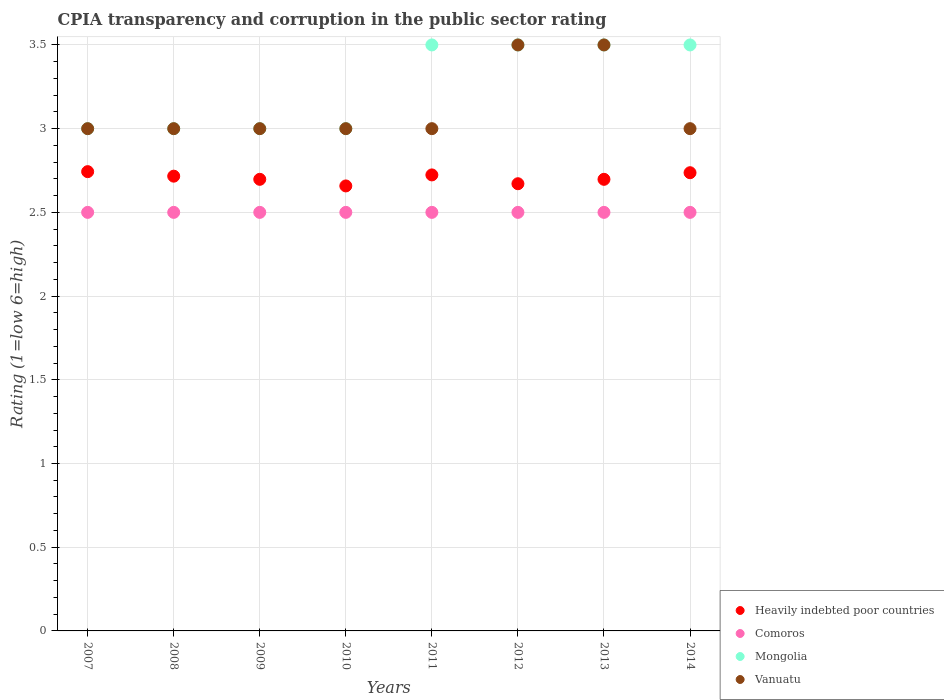Is the number of dotlines equal to the number of legend labels?
Offer a very short reply. Yes. Across all years, what is the maximum CPIA rating in Vanuatu?
Your answer should be compact. 3.5. Across all years, what is the minimum CPIA rating in Vanuatu?
Provide a succinct answer. 3. In which year was the CPIA rating in Vanuatu maximum?
Your response must be concise. 2012. In which year was the CPIA rating in Comoros minimum?
Provide a succinct answer. 2007. What is the difference between the CPIA rating in Mongolia in 2007 and that in 2012?
Offer a terse response. -0.5. In the year 2011, what is the difference between the CPIA rating in Vanuatu and CPIA rating in Heavily indebted poor countries?
Provide a short and direct response. 0.28. In how many years, is the CPIA rating in Comoros greater than 1.5?
Ensure brevity in your answer.  8. Is the CPIA rating in Heavily indebted poor countries in 2011 less than that in 2014?
Your response must be concise. Yes. What is the difference between the highest and the second highest CPIA rating in Heavily indebted poor countries?
Ensure brevity in your answer.  0.01. What is the difference between the highest and the lowest CPIA rating in Vanuatu?
Your answer should be compact. 0.5. Is the sum of the CPIA rating in Heavily indebted poor countries in 2010 and 2014 greater than the maximum CPIA rating in Vanuatu across all years?
Your answer should be compact. Yes. Is it the case that in every year, the sum of the CPIA rating in Mongolia and CPIA rating in Vanuatu  is greater than the sum of CPIA rating in Heavily indebted poor countries and CPIA rating in Comoros?
Provide a succinct answer. Yes. Is the CPIA rating in Heavily indebted poor countries strictly less than the CPIA rating in Comoros over the years?
Provide a short and direct response. No. Does the graph contain any zero values?
Ensure brevity in your answer.  No. Where does the legend appear in the graph?
Make the answer very short. Bottom right. What is the title of the graph?
Give a very brief answer. CPIA transparency and corruption in the public sector rating. Does "United States" appear as one of the legend labels in the graph?
Provide a short and direct response. No. What is the label or title of the X-axis?
Provide a short and direct response. Years. What is the Rating (1=low 6=high) of Heavily indebted poor countries in 2007?
Offer a terse response. 2.74. What is the Rating (1=low 6=high) of Heavily indebted poor countries in 2008?
Your answer should be very brief. 2.72. What is the Rating (1=low 6=high) in Mongolia in 2008?
Your answer should be compact. 3. What is the Rating (1=low 6=high) in Heavily indebted poor countries in 2009?
Give a very brief answer. 2.7. What is the Rating (1=low 6=high) in Vanuatu in 2009?
Your answer should be compact. 3. What is the Rating (1=low 6=high) of Heavily indebted poor countries in 2010?
Your response must be concise. 2.66. What is the Rating (1=low 6=high) of Vanuatu in 2010?
Offer a very short reply. 3. What is the Rating (1=low 6=high) in Heavily indebted poor countries in 2011?
Provide a succinct answer. 2.72. What is the Rating (1=low 6=high) in Heavily indebted poor countries in 2012?
Your answer should be compact. 2.67. What is the Rating (1=low 6=high) of Heavily indebted poor countries in 2013?
Provide a succinct answer. 2.7. What is the Rating (1=low 6=high) of Comoros in 2013?
Your answer should be very brief. 2.5. What is the Rating (1=low 6=high) of Heavily indebted poor countries in 2014?
Provide a succinct answer. 2.74. What is the Rating (1=low 6=high) of Mongolia in 2014?
Your response must be concise. 3.5. Across all years, what is the maximum Rating (1=low 6=high) in Heavily indebted poor countries?
Provide a succinct answer. 2.74. Across all years, what is the maximum Rating (1=low 6=high) of Vanuatu?
Make the answer very short. 3.5. Across all years, what is the minimum Rating (1=low 6=high) of Heavily indebted poor countries?
Keep it short and to the point. 2.66. Across all years, what is the minimum Rating (1=low 6=high) in Mongolia?
Make the answer very short. 3. What is the total Rating (1=low 6=high) in Heavily indebted poor countries in the graph?
Provide a short and direct response. 21.64. What is the total Rating (1=low 6=high) in Comoros in the graph?
Provide a succinct answer. 20. What is the total Rating (1=low 6=high) of Mongolia in the graph?
Offer a very short reply. 26. What is the difference between the Rating (1=low 6=high) of Heavily indebted poor countries in 2007 and that in 2008?
Your response must be concise. 0.03. What is the difference between the Rating (1=low 6=high) of Comoros in 2007 and that in 2008?
Offer a terse response. 0. What is the difference between the Rating (1=low 6=high) in Mongolia in 2007 and that in 2008?
Offer a terse response. 0. What is the difference between the Rating (1=low 6=high) of Vanuatu in 2007 and that in 2008?
Give a very brief answer. 0. What is the difference between the Rating (1=low 6=high) in Heavily indebted poor countries in 2007 and that in 2009?
Offer a very short reply. 0.05. What is the difference between the Rating (1=low 6=high) in Mongolia in 2007 and that in 2009?
Your answer should be compact. 0. What is the difference between the Rating (1=low 6=high) in Heavily indebted poor countries in 2007 and that in 2010?
Offer a terse response. 0.09. What is the difference between the Rating (1=low 6=high) in Heavily indebted poor countries in 2007 and that in 2011?
Keep it short and to the point. 0.02. What is the difference between the Rating (1=low 6=high) of Comoros in 2007 and that in 2011?
Give a very brief answer. 0. What is the difference between the Rating (1=low 6=high) in Vanuatu in 2007 and that in 2011?
Provide a short and direct response. 0. What is the difference between the Rating (1=low 6=high) in Heavily indebted poor countries in 2007 and that in 2012?
Offer a very short reply. 0.07. What is the difference between the Rating (1=low 6=high) of Mongolia in 2007 and that in 2012?
Keep it short and to the point. -0.5. What is the difference between the Rating (1=low 6=high) of Vanuatu in 2007 and that in 2012?
Offer a very short reply. -0.5. What is the difference between the Rating (1=low 6=high) in Heavily indebted poor countries in 2007 and that in 2013?
Your answer should be very brief. 0.05. What is the difference between the Rating (1=low 6=high) in Comoros in 2007 and that in 2013?
Offer a very short reply. 0. What is the difference between the Rating (1=low 6=high) in Mongolia in 2007 and that in 2013?
Offer a very short reply. -0.5. What is the difference between the Rating (1=low 6=high) of Heavily indebted poor countries in 2007 and that in 2014?
Ensure brevity in your answer.  0.01. What is the difference between the Rating (1=low 6=high) of Mongolia in 2007 and that in 2014?
Provide a succinct answer. -0.5. What is the difference between the Rating (1=low 6=high) of Heavily indebted poor countries in 2008 and that in 2009?
Offer a terse response. 0.02. What is the difference between the Rating (1=low 6=high) of Heavily indebted poor countries in 2008 and that in 2010?
Give a very brief answer. 0.06. What is the difference between the Rating (1=low 6=high) of Vanuatu in 2008 and that in 2010?
Your answer should be compact. 0. What is the difference between the Rating (1=low 6=high) of Heavily indebted poor countries in 2008 and that in 2011?
Your answer should be compact. -0.01. What is the difference between the Rating (1=low 6=high) in Mongolia in 2008 and that in 2011?
Your response must be concise. -0.5. What is the difference between the Rating (1=low 6=high) of Vanuatu in 2008 and that in 2011?
Keep it short and to the point. 0. What is the difference between the Rating (1=low 6=high) of Heavily indebted poor countries in 2008 and that in 2012?
Provide a short and direct response. 0.05. What is the difference between the Rating (1=low 6=high) of Heavily indebted poor countries in 2008 and that in 2013?
Provide a succinct answer. 0.02. What is the difference between the Rating (1=low 6=high) in Heavily indebted poor countries in 2008 and that in 2014?
Your answer should be compact. -0.02. What is the difference between the Rating (1=low 6=high) of Heavily indebted poor countries in 2009 and that in 2010?
Make the answer very short. 0.04. What is the difference between the Rating (1=low 6=high) in Mongolia in 2009 and that in 2010?
Your response must be concise. 0. What is the difference between the Rating (1=low 6=high) in Heavily indebted poor countries in 2009 and that in 2011?
Keep it short and to the point. -0.03. What is the difference between the Rating (1=low 6=high) in Comoros in 2009 and that in 2011?
Give a very brief answer. 0. What is the difference between the Rating (1=low 6=high) in Heavily indebted poor countries in 2009 and that in 2012?
Ensure brevity in your answer.  0.03. What is the difference between the Rating (1=low 6=high) in Comoros in 2009 and that in 2012?
Offer a very short reply. 0. What is the difference between the Rating (1=low 6=high) in Mongolia in 2009 and that in 2012?
Keep it short and to the point. -0.5. What is the difference between the Rating (1=low 6=high) in Vanuatu in 2009 and that in 2012?
Ensure brevity in your answer.  -0.5. What is the difference between the Rating (1=low 6=high) in Heavily indebted poor countries in 2009 and that in 2013?
Your answer should be very brief. 0. What is the difference between the Rating (1=low 6=high) of Comoros in 2009 and that in 2013?
Your answer should be very brief. 0. What is the difference between the Rating (1=low 6=high) of Mongolia in 2009 and that in 2013?
Your response must be concise. -0.5. What is the difference between the Rating (1=low 6=high) in Heavily indebted poor countries in 2009 and that in 2014?
Provide a short and direct response. -0.04. What is the difference between the Rating (1=low 6=high) in Heavily indebted poor countries in 2010 and that in 2011?
Provide a succinct answer. -0.07. What is the difference between the Rating (1=low 6=high) in Comoros in 2010 and that in 2011?
Your answer should be compact. 0. What is the difference between the Rating (1=low 6=high) in Heavily indebted poor countries in 2010 and that in 2012?
Provide a short and direct response. -0.01. What is the difference between the Rating (1=low 6=high) of Heavily indebted poor countries in 2010 and that in 2013?
Your answer should be compact. -0.04. What is the difference between the Rating (1=low 6=high) of Comoros in 2010 and that in 2013?
Your response must be concise. 0. What is the difference between the Rating (1=low 6=high) in Heavily indebted poor countries in 2010 and that in 2014?
Make the answer very short. -0.08. What is the difference between the Rating (1=low 6=high) in Comoros in 2010 and that in 2014?
Give a very brief answer. 0. What is the difference between the Rating (1=low 6=high) of Mongolia in 2010 and that in 2014?
Your answer should be very brief. -0.5. What is the difference between the Rating (1=low 6=high) in Vanuatu in 2010 and that in 2014?
Give a very brief answer. 0. What is the difference between the Rating (1=low 6=high) in Heavily indebted poor countries in 2011 and that in 2012?
Ensure brevity in your answer.  0.05. What is the difference between the Rating (1=low 6=high) in Vanuatu in 2011 and that in 2012?
Provide a succinct answer. -0.5. What is the difference between the Rating (1=low 6=high) in Heavily indebted poor countries in 2011 and that in 2013?
Provide a succinct answer. 0.03. What is the difference between the Rating (1=low 6=high) in Comoros in 2011 and that in 2013?
Offer a terse response. 0. What is the difference between the Rating (1=low 6=high) in Vanuatu in 2011 and that in 2013?
Provide a succinct answer. -0.5. What is the difference between the Rating (1=low 6=high) of Heavily indebted poor countries in 2011 and that in 2014?
Ensure brevity in your answer.  -0.01. What is the difference between the Rating (1=low 6=high) of Mongolia in 2011 and that in 2014?
Your answer should be very brief. 0. What is the difference between the Rating (1=low 6=high) of Vanuatu in 2011 and that in 2014?
Offer a terse response. 0. What is the difference between the Rating (1=low 6=high) in Heavily indebted poor countries in 2012 and that in 2013?
Offer a very short reply. -0.03. What is the difference between the Rating (1=low 6=high) in Comoros in 2012 and that in 2013?
Give a very brief answer. 0. What is the difference between the Rating (1=low 6=high) of Vanuatu in 2012 and that in 2013?
Make the answer very short. 0. What is the difference between the Rating (1=low 6=high) in Heavily indebted poor countries in 2012 and that in 2014?
Make the answer very short. -0.07. What is the difference between the Rating (1=low 6=high) in Comoros in 2012 and that in 2014?
Your answer should be very brief. 0. What is the difference between the Rating (1=low 6=high) of Mongolia in 2012 and that in 2014?
Offer a terse response. 0. What is the difference between the Rating (1=low 6=high) in Vanuatu in 2012 and that in 2014?
Provide a succinct answer. 0.5. What is the difference between the Rating (1=low 6=high) of Heavily indebted poor countries in 2013 and that in 2014?
Make the answer very short. -0.04. What is the difference between the Rating (1=low 6=high) of Comoros in 2013 and that in 2014?
Your answer should be very brief. 0. What is the difference between the Rating (1=low 6=high) in Vanuatu in 2013 and that in 2014?
Make the answer very short. 0.5. What is the difference between the Rating (1=low 6=high) in Heavily indebted poor countries in 2007 and the Rating (1=low 6=high) in Comoros in 2008?
Give a very brief answer. 0.24. What is the difference between the Rating (1=low 6=high) of Heavily indebted poor countries in 2007 and the Rating (1=low 6=high) of Mongolia in 2008?
Provide a succinct answer. -0.26. What is the difference between the Rating (1=low 6=high) in Heavily indebted poor countries in 2007 and the Rating (1=low 6=high) in Vanuatu in 2008?
Provide a short and direct response. -0.26. What is the difference between the Rating (1=low 6=high) in Comoros in 2007 and the Rating (1=low 6=high) in Mongolia in 2008?
Keep it short and to the point. -0.5. What is the difference between the Rating (1=low 6=high) of Comoros in 2007 and the Rating (1=low 6=high) of Vanuatu in 2008?
Offer a terse response. -0.5. What is the difference between the Rating (1=low 6=high) in Heavily indebted poor countries in 2007 and the Rating (1=low 6=high) in Comoros in 2009?
Offer a terse response. 0.24. What is the difference between the Rating (1=low 6=high) in Heavily indebted poor countries in 2007 and the Rating (1=low 6=high) in Mongolia in 2009?
Provide a succinct answer. -0.26. What is the difference between the Rating (1=low 6=high) in Heavily indebted poor countries in 2007 and the Rating (1=low 6=high) in Vanuatu in 2009?
Provide a short and direct response. -0.26. What is the difference between the Rating (1=low 6=high) in Comoros in 2007 and the Rating (1=low 6=high) in Mongolia in 2009?
Keep it short and to the point. -0.5. What is the difference between the Rating (1=low 6=high) in Comoros in 2007 and the Rating (1=low 6=high) in Vanuatu in 2009?
Provide a short and direct response. -0.5. What is the difference between the Rating (1=low 6=high) of Heavily indebted poor countries in 2007 and the Rating (1=low 6=high) of Comoros in 2010?
Ensure brevity in your answer.  0.24. What is the difference between the Rating (1=low 6=high) of Heavily indebted poor countries in 2007 and the Rating (1=low 6=high) of Mongolia in 2010?
Keep it short and to the point. -0.26. What is the difference between the Rating (1=low 6=high) of Heavily indebted poor countries in 2007 and the Rating (1=low 6=high) of Vanuatu in 2010?
Keep it short and to the point. -0.26. What is the difference between the Rating (1=low 6=high) of Comoros in 2007 and the Rating (1=low 6=high) of Mongolia in 2010?
Offer a terse response. -0.5. What is the difference between the Rating (1=low 6=high) of Comoros in 2007 and the Rating (1=low 6=high) of Vanuatu in 2010?
Your answer should be compact. -0.5. What is the difference between the Rating (1=low 6=high) in Mongolia in 2007 and the Rating (1=low 6=high) in Vanuatu in 2010?
Offer a very short reply. 0. What is the difference between the Rating (1=low 6=high) in Heavily indebted poor countries in 2007 and the Rating (1=low 6=high) in Comoros in 2011?
Offer a terse response. 0.24. What is the difference between the Rating (1=low 6=high) of Heavily indebted poor countries in 2007 and the Rating (1=low 6=high) of Mongolia in 2011?
Give a very brief answer. -0.76. What is the difference between the Rating (1=low 6=high) in Heavily indebted poor countries in 2007 and the Rating (1=low 6=high) in Vanuatu in 2011?
Your answer should be very brief. -0.26. What is the difference between the Rating (1=low 6=high) of Mongolia in 2007 and the Rating (1=low 6=high) of Vanuatu in 2011?
Your response must be concise. 0. What is the difference between the Rating (1=low 6=high) of Heavily indebted poor countries in 2007 and the Rating (1=low 6=high) of Comoros in 2012?
Make the answer very short. 0.24. What is the difference between the Rating (1=low 6=high) of Heavily indebted poor countries in 2007 and the Rating (1=low 6=high) of Mongolia in 2012?
Offer a very short reply. -0.76. What is the difference between the Rating (1=low 6=high) of Heavily indebted poor countries in 2007 and the Rating (1=low 6=high) of Vanuatu in 2012?
Offer a very short reply. -0.76. What is the difference between the Rating (1=low 6=high) in Comoros in 2007 and the Rating (1=low 6=high) in Mongolia in 2012?
Make the answer very short. -1. What is the difference between the Rating (1=low 6=high) of Mongolia in 2007 and the Rating (1=low 6=high) of Vanuatu in 2012?
Ensure brevity in your answer.  -0.5. What is the difference between the Rating (1=low 6=high) in Heavily indebted poor countries in 2007 and the Rating (1=low 6=high) in Comoros in 2013?
Your response must be concise. 0.24. What is the difference between the Rating (1=low 6=high) in Heavily indebted poor countries in 2007 and the Rating (1=low 6=high) in Mongolia in 2013?
Offer a very short reply. -0.76. What is the difference between the Rating (1=low 6=high) in Heavily indebted poor countries in 2007 and the Rating (1=low 6=high) in Vanuatu in 2013?
Your answer should be compact. -0.76. What is the difference between the Rating (1=low 6=high) of Comoros in 2007 and the Rating (1=low 6=high) of Mongolia in 2013?
Make the answer very short. -1. What is the difference between the Rating (1=low 6=high) in Comoros in 2007 and the Rating (1=low 6=high) in Vanuatu in 2013?
Provide a short and direct response. -1. What is the difference between the Rating (1=low 6=high) of Heavily indebted poor countries in 2007 and the Rating (1=low 6=high) of Comoros in 2014?
Your answer should be very brief. 0.24. What is the difference between the Rating (1=low 6=high) in Heavily indebted poor countries in 2007 and the Rating (1=low 6=high) in Mongolia in 2014?
Offer a very short reply. -0.76. What is the difference between the Rating (1=low 6=high) in Heavily indebted poor countries in 2007 and the Rating (1=low 6=high) in Vanuatu in 2014?
Your response must be concise. -0.26. What is the difference between the Rating (1=low 6=high) of Comoros in 2007 and the Rating (1=low 6=high) of Vanuatu in 2014?
Your response must be concise. -0.5. What is the difference between the Rating (1=low 6=high) in Mongolia in 2007 and the Rating (1=low 6=high) in Vanuatu in 2014?
Your answer should be compact. 0. What is the difference between the Rating (1=low 6=high) of Heavily indebted poor countries in 2008 and the Rating (1=low 6=high) of Comoros in 2009?
Make the answer very short. 0.22. What is the difference between the Rating (1=low 6=high) in Heavily indebted poor countries in 2008 and the Rating (1=low 6=high) in Mongolia in 2009?
Provide a short and direct response. -0.28. What is the difference between the Rating (1=low 6=high) of Heavily indebted poor countries in 2008 and the Rating (1=low 6=high) of Vanuatu in 2009?
Your answer should be compact. -0.28. What is the difference between the Rating (1=low 6=high) in Comoros in 2008 and the Rating (1=low 6=high) in Mongolia in 2009?
Offer a terse response. -0.5. What is the difference between the Rating (1=low 6=high) of Heavily indebted poor countries in 2008 and the Rating (1=low 6=high) of Comoros in 2010?
Offer a very short reply. 0.22. What is the difference between the Rating (1=low 6=high) of Heavily indebted poor countries in 2008 and the Rating (1=low 6=high) of Mongolia in 2010?
Offer a terse response. -0.28. What is the difference between the Rating (1=low 6=high) in Heavily indebted poor countries in 2008 and the Rating (1=low 6=high) in Vanuatu in 2010?
Offer a terse response. -0.28. What is the difference between the Rating (1=low 6=high) of Comoros in 2008 and the Rating (1=low 6=high) of Mongolia in 2010?
Your response must be concise. -0.5. What is the difference between the Rating (1=low 6=high) in Mongolia in 2008 and the Rating (1=low 6=high) in Vanuatu in 2010?
Provide a succinct answer. 0. What is the difference between the Rating (1=low 6=high) in Heavily indebted poor countries in 2008 and the Rating (1=low 6=high) in Comoros in 2011?
Give a very brief answer. 0.22. What is the difference between the Rating (1=low 6=high) of Heavily indebted poor countries in 2008 and the Rating (1=low 6=high) of Mongolia in 2011?
Give a very brief answer. -0.78. What is the difference between the Rating (1=low 6=high) of Heavily indebted poor countries in 2008 and the Rating (1=low 6=high) of Vanuatu in 2011?
Provide a succinct answer. -0.28. What is the difference between the Rating (1=low 6=high) in Comoros in 2008 and the Rating (1=low 6=high) in Mongolia in 2011?
Provide a short and direct response. -1. What is the difference between the Rating (1=low 6=high) of Comoros in 2008 and the Rating (1=low 6=high) of Vanuatu in 2011?
Keep it short and to the point. -0.5. What is the difference between the Rating (1=low 6=high) of Mongolia in 2008 and the Rating (1=low 6=high) of Vanuatu in 2011?
Make the answer very short. 0. What is the difference between the Rating (1=low 6=high) of Heavily indebted poor countries in 2008 and the Rating (1=low 6=high) of Comoros in 2012?
Provide a short and direct response. 0.22. What is the difference between the Rating (1=low 6=high) in Heavily indebted poor countries in 2008 and the Rating (1=low 6=high) in Mongolia in 2012?
Offer a very short reply. -0.78. What is the difference between the Rating (1=low 6=high) of Heavily indebted poor countries in 2008 and the Rating (1=low 6=high) of Vanuatu in 2012?
Give a very brief answer. -0.78. What is the difference between the Rating (1=low 6=high) in Comoros in 2008 and the Rating (1=low 6=high) in Mongolia in 2012?
Ensure brevity in your answer.  -1. What is the difference between the Rating (1=low 6=high) of Comoros in 2008 and the Rating (1=low 6=high) of Vanuatu in 2012?
Your answer should be very brief. -1. What is the difference between the Rating (1=low 6=high) in Heavily indebted poor countries in 2008 and the Rating (1=low 6=high) in Comoros in 2013?
Provide a short and direct response. 0.22. What is the difference between the Rating (1=low 6=high) in Heavily indebted poor countries in 2008 and the Rating (1=low 6=high) in Mongolia in 2013?
Your response must be concise. -0.78. What is the difference between the Rating (1=low 6=high) in Heavily indebted poor countries in 2008 and the Rating (1=low 6=high) in Vanuatu in 2013?
Give a very brief answer. -0.78. What is the difference between the Rating (1=low 6=high) of Comoros in 2008 and the Rating (1=low 6=high) of Mongolia in 2013?
Make the answer very short. -1. What is the difference between the Rating (1=low 6=high) in Comoros in 2008 and the Rating (1=low 6=high) in Vanuatu in 2013?
Ensure brevity in your answer.  -1. What is the difference between the Rating (1=low 6=high) in Mongolia in 2008 and the Rating (1=low 6=high) in Vanuatu in 2013?
Provide a short and direct response. -0.5. What is the difference between the Rating (1=low 6=high) in Heavily indebted poor countries in 2008 and the Rating (1=low 6=high) in Comoros in 2014?
Offer a terse response. 0.22. What is the difference between the Rating (1=low 6=high) in Heavily indebted poor countries in 2008 and the Rating (1=low 6=high) in Mongolia in 2014?
Your answer should be very brief. -0.78. What is the difference between the Rating (1=low 6=high) of Heavily indebted poor countries in 2008 and the Rating (1=low 6=high) of Vanuatu in 2014?
Offer a very short reply. -0.28. What is the difference between the Rating (1=low 6=high) in Comoros in 2008 and the Rating (1=low 6=high) in Vanuatu in 2014?
Your response must be concise. -0.5. What is the difference between the Rating (1=low 6=high) in Heavily indebted poor countries in 2009 and the Rating (1=low 6=high) in Comoros in 2010?
Your response must be concise. 0.2. What is the difference between the Rating (1=low 6=high) of Heavily indebted poor countries in 2009 and the Rating (1=low 6=high) of Mongolia in 2010?
Provide a succinct answer. -0.3. What is the difference between the Rating (1=low 6=high) in Heavily indebted poor countries in 2009 and the Rating (1=low 6=high) in Vanuatu in 2010?
Offer a very short reply. -0.3. What is the difference between the Rating (1=low 6=high) of Mongolia in 2009 and the Rating (1=low 6=high) of Vanuatu in 2010?
Keep it short and to the point. 0. What is the difference between the Rating (1=low 6=high) in Heavily indebted poor countries in 2009 and the Rating (1=low 6=high) in Comoros in 2011?
Give a very brief answer. 0.2. What is the difference between the Rating (1=low 6=high) in Heavily indebted poor countries in 2009 and the Rating (1=low 6=high) in Mongolia in 2011?
Your answer should be compact. -0.8. What is the difference between the Rating (1=low 6=high) in Heavily indebted poor countries in 2009 and the Rating (1=low 6=high) in Vanuatu in 2011?
Offer a very short reply. -0.3. What is the difference between the Rating (1=low 6=high) of Comoros in 2009 and the Rating (1=low 6=high) of Vanuatu in 2011?
Make the answer very short. -0.5. What is the difference between the Rating (1=low 6=high) in Mongolia in 2009 and the Rating (1=low 6=high) in Vanuatu in 2011?
Your answer should be very brief. 0. What is the difference between the Rating (1=low 6=high) in Heavily indebted poor countries in 2009 and the Rating (1=low 6=high) in Comoros in 2012?
Your answer should be compact. 0.2. What is the difference between the Rating (1=low 6=high) of Heavily indebted poor countries in 2009 and the Rating (1=low 6=high) of Mongolia in 2012?
Offer a terse response. -0.8. What is the difference between the Rating (1=low 6=high) in Heavily indebted poor countries in 2009 and the Rating (1=low 6=high) in Vanuatu in 2012?
Your answer should be compact. -0.8. What is the difference between the Rating (1=low 6=high) in Comoros in 2009 and the Rating (1=low 6=high) in Mongolia in 2012?
Keep it short and to the point. -1. What is the difference between the Rating (1=low 6=high) in Comoros in 2009 and the Rating (1=low 6=high) in Vanuatu in 2012?
Offer a very short reply. -1. What is the difference between the Rating (1=low 6=high) in Mongolia in 2009 and the Rating (1=low 6=high) in Vanuatu in 2012?
Your answer should be compact. -0.5. What is the difference between the Rating (1=low 6=high) of Heavily indebted poor countries in 2009 and the Rating (1=low 6=high) of Comoros in 2013?
Your response must be concise. 0.2. What is the difference between the Rating (1=low 6=high) of Heavily indebted poor countries in 2009 and the Rating (1=low 6=high) of Mongolia in 2013?
Offer a terse response. -0.8. What is the difference between the Rating (1=low 6=high) of Heavily indebted poor countries in 2009 and the Rating (1=low 6=high) of Vanuatu in 2013?
Give a very brief answer. -0.8. What is the difference between the Rating (1=low 6=high) in Comoros in 2009 and the Rating (1=low 6=high) in Vanuatu in 2013?
Your answer should be very brief. -1. What is the difference between the Rating (1=low 6=high) of Heavily indebted poor countries in 2009 and the Rating (1=low 6=high) of Comoros in 2014?
Offer a terse response. 0.2. What is the difference between the Rating (1=low 6=high) of Heavily indebted poor countries in 2009 and the Rating (1=low 6=high) of Mongolia in 2014?
Make the answer very short. -0.8. What is the difference between the Rating (1=low 6=high) in Heavily indebted poor countries in 2009 and the Rating (1=low 6=high) in Vanuatu in 2014?
Provide a succinct answer. -0.3. What is the difference between the Rating (1=low 6=high) in Comoros in 2009 and the Rating (1=low 6=high) in Mongolia in 2014?
Your answer should be very brief. -1. What is the difference between the Rating (1=low 6=high) of Mongolia in 2009 and the Rating (1=low 6=high) of Vanuatu in 2014?
Your response must be concise. 0. What is the difference between the Rating (1=low 6=high) in Heavily indebted poor countries in 2010 and the Rating (1=low 6=high) in Comoros in 2011?
Make the answer very short. 0.16. What is the difference between the Rating (1=low 6=high) in Heavily indebted poor countries in 2010 and the Rating (1=low 6=high) in Mongolia in 2011?
Your response must be concise. -0.84. What is the difference between the Rating (1=low 6=high) in Heavily indebted poor countries in 2010 and the Rating (1=low 6=high) in Vanuatu in 2011?
Offer a terse response. -0.34. What is the difference between the Rating (1=low 6=high) of Comoros in 2010 and the Rating (1=low 6=high) of Vanuatu in 2011?
Your answer should be compact. -0.5. What is the difference between the Rating (1=low 6=high) in Heavily indebted poor countries in 2010 and the Rating (1=low 6=high) in Comoros in 2012?
Your answer should be compact. 0.16. What is the difference between the Rating (1=low 6=high) in Heavily indebted poor countries in 2010 and the Rating (1=low 6=high) in Mongolia in 2012?
Make the answer very short. -0.84. What is the difference between the Rating (1=low 6=high) of Heavily indebted poor countries in 2010 and the Rating (1=low 6=high) of Vanuatu in 2012?
Keep it short and to the point. -0.84. What is the difference between the Rating (1=low 6=high) in Comoros in 2010 and the Rating (1=low 6=high) in Mongolia in 2012?
Your answer should be very brief. -1. What is the difference between the Rating (1=low 6=high) of Mongolia in 2010 and the Rating (1=low 6=high) of Vanuatu in 2012?
Provide a succinct answer. -0.5. What is the difference between the Rating (1=low 6=high) of Heavily indebted poor countries in 2010 and the Rating (1=low 6=high) of Comoros in 2013?
Provide a short and direct response. 0.16. What is the difference between the Rating (1=low 6=high) of Heavily indebted poor countries in 2010 and the Rating (1=low 6=high) of Mongolia in 2013?
Provide a short and direct response. -0.84. What is the difference between the Rating (1=low 6=high) in Heavily indebted poor countries in 2010 and the Rating (1=low 6=high) in Vanuatu in 2013?
Your answer should be very brief. -0.84. What is the difference between the Rating (1=low 6=high) in Comoros in 2010 and the Rating (1=low 6=high) in Mongolia in 2013?
Ensure brevity in your answer.  -1. What is the difference between the Rating (1=low 6=high) in Heavily indebted poor countries in 2010 and the Rating (1=low 6=high) in Comoros in 2014?
Ensure brevity in your answer.  0.16. What is the difference between the Rating (1=low 6=high) of Heavily indebted poor countries in 2010 and the Rating (1=low 6=high) of Mongolia in 2014?
Your response must be concise. -0.84. What is the difference between the Rating (1=low 6=high) in Heavily indebted poor countries in 2010 and the Rating (1=low 6=high) in Vanuatu in 2014?
Offer a terse response. -0.34. What is the difference between the Rating (1=low 6=high) in Comoros in 2010 and the Rating (1=low 6=high) in Mongolia in 2014?
Give a very brief answer. -1. What is the difference between the Rating (1=low 6=high) in Heavily indebted poor countries in 2011 and the Rating (1=low 6=high) in Comoros in 2012?
Provide a succinct answer. 0.22. What is the difference between the Rating (1=low 6=high) of Heavily indebted poor countries in 2011 and the Rating (1=low 6=high) of Mongolia in 2012?
Your response must be concise. -0.78. What is the difference between the Rating (1=low 6=high) in Heavily indebted poor countries in 2011 and the Rating (1=low 6=high) in Vanuatu in 2012?
Give a very brief answer. -0.78. What is the difference between the Rating (1=low 6=high) in Comoros in 2011 and the Rating (1=low 6=high) in Mongolia in 2012?
Offer a terse response. -1. What is the difference between the Rating (1=low 6=high) of Comoros in 2011 and the Rating (1=low 6=high) of Vanuatu in 2012?
Your answer should be very brief. -1. What is the difference between the Rating (1=low 6=high) of Mongolia in 2011 and the Rating (1=low 6=high) of Vanuatu in 2012?
Ensure brevity in your answer.  0. What is the difference between the Rating (1=low 6=high) of Heavily indebted poor countries in 2011 and the Rating (1=low 6=high) of Comoros in 2013?
Give a very brief answer. 0.22. What is the difference between the Rating (1=low 6=high) of Heavily indebted poor countries in 2011 and the Rating (1=low 6=high) of Mongolia in 2013?
Make the answer very short. -0.78. What is the difference between the Rating (1=low 6=high) of Heavily indebted poor countries in 2011 and the Rating (1=low 6=high) of Vanuatu in 2013?
Your answer should be compact. -0.78. What is the difference between the Rating (1=low 6=high) in Comoros in 2011 and the Rating (1=low 6=high) in Mongolia in 2013?
Provide a succinct answer. -1. What is the difference between the Rating (1=low 6=high) in Mongolia in 2011 and the Rating (1=low 6=high) in Vanuatu in 2013?
Give a very brief answer. 0. What is the difference between the Rating (1=low 6=high) in Heavily indebted poor countries in 2011 and the Rating (1=low 6=high) in Comoros in 2014?
Give a very brief answer. 0.22. What is the difference between the Rating (1=low 6=high) of Heavily indebted poor countries in 2011 and the Rating (1=low 6=high) of Mongolia in 2014?
Your response must be concise. -0.78. What is the difference between the Rating (1=low 6=high) in Heavily indebted poor countries in 2011 and the Rating (1=low 6=high) in Vanuatu in 2014?
Offer a terse response. -0.28. What is the difference between the Rating (1=low 6=high) of Mongolia in 2011 and the Rating (1=low 6=high) of Vanuatu in 2014?
Give a very brief answer. 0.5. What is the difference between the Rating (1=low 6=high) of Heavily indebted poor countries in 2012 and the Rating (1=low 6=high) of Comoros in 2013?
Give a very brief answer. 0.17. What is the difference between the Rating (1=low 6=high) of Heavily indebted poor countries in 2012 and the Rating (1=low 6=high) of Mongolia in 2013?
Offer a very short reply. -0.83. What is the difference between the Rating (1=low 6=high) in Heavily indebted poor countries in 2012 and the Rating (1=low 6=high) in Vanuatu in 2013?
Keep it short and to the point. -0.83. What is the difference between the Rating (1=low 6=high) in Comoros in 2012 and the Rating (1=low 6=high) in Mongolia in 2013?
Provide a succinct answer. -1. What is the difference between the Rating (1=low 6=high) in Comoros in 2012 and the Rating (1=low 6=high) in Vanuatu in 2013?
Provide a succinct answer. -1. What is the difference between the Rating (1=low 6=high) in Heavily indebted poor countries in 2012 and the Rating (1=low 6=high) in Comoros in 2014?
Make the answer very short. 0.17. What is the difference between the Rating (1=low 6=high) of Heavily indebted poor countries in 2012 and the Rating (1=low 6=high) of Mongolia in 2014?
Provide a short and direct response. -0.83. What is the difference between the Rating (1=low 6=high) of Heavily indebted poor countries in 2012 and the Rating (1=low 6=high) of Vanuatu in 2014?
Your response must be concise. -0.33. What is the difference between the Rating (1=low 6=high) in Mongolia in 2012 and the Rating (1=low 6=high) in Vanuatu in 2014?
Give a very brief answer. 0.5. What is the difference between the Rating (1=low 6=high) of Heavily indebted poor countries in 2013 and the Rating (1=low 6=high) of Comoros in 2014?
Make the answer very short. 0.2. What is the difference between the Rating (1=low 6=high) of Heavily indebted poor countries in 2013 and the Rating (1=low 6=high) of Mongolia in 2014?
Offer a very short reply. -0.8. What is the difference between the Rating (1=low 6=high) of Heavily indebted poor countries in 2013 and the Rating (1=low 6=high) of Vanuatu in 2014?
Provide a short and direct response. -0.3. What is the difference between the Rating (1=low 6=high) in Comoros in 2013 and the Rating (1=low 6=high) in Mongolia in 2014?
Offer a terse response. -1. What is the difference between the Rating (1=low 6=high) of Comoros in 2013 and the Rating (1=low 6=high) of Vanuatu in 2014?
Offer a terse response. -0.5. What is the difference between the Rating (1=low 6=high) in Mongolia in 2013 and the Rating (1=low 6=high) in Vanuatu in 2014?
Ensure brevity in your answer.  0.5. What is the average Rating (1=low 6=high) in Heavily indebted poor countries per year?
Provide a short and direct response. 2.71. What is the average Rating (1=low 6=high) of Mongolia per year?
Your answer should be very brief. 3.25. What is the average Rating (1=low 6=high) of Vanuatu per year?
Your response must be concise. 3.12. In the year 2007, what is the difference between the Rating (1=low 6=high) of Heavily indebted poor countries and Rating (1=low 6=high) of Comoros?
Make the answer very short. 0.24. In the year 2007, what is the difference between the Rating (1=low 6=high) of Heavily indebted poor countries and Rating (1=low 6=high) of Mongolia?
Keep it short and to the point. -0.26. In the year 2007, what is the difference between the Rating (1=low 6=high) of Heavily indebted poor countries and Rating (1=low 6=high) of Vanuatu?
Make the answer very short. -0.26. In the year 2007, what is the difference between the Rating (1=low 6=high) in Comoros and Rating (1=low 6=high) in Mongolia?
Your answer should be compact. -0.5. In the year 2008, what is the difference between the Rating (1=low 6=high) in Heavily indebted poor countries and Rating (1=low 6=high) in Comoros?
Provide a succinct answer. 0.22. In the year 2008, what is the difference between the Rating (1=low 6=high) of Heavily indebted poor countries and Rating (1=low 6=high) of Mongolia?
Ensure brevity in your answer.  -0.28. In the year 2008, what is the difference between the Rating (1=low 6=high) of Heavily indebted poor countries and Rating (1=low 6=high) of Vanuatu?
Your answer should be compact. -0.28. In the year 2008, what is the difference between the Rating (1=low 6=high) of Comoros and Rating (1=low 6=high) of Mongolia?
Your response must be concise. -0.5. In the year 2008, what is the difference between the Rating (1=low 6=high) of Comoros and Rating (1=low 6=high) of Vanuatu?
Give a very brief answer. -0.5. In the year 2008, what is the difference between the Rating (1=low 6=high) in Mongolia and Rating (1=low 6=high) in Vanuatu?
Your answer should be very brief. 0. In the year 2009, what is the difference between the Rating (1=low 6=high) of Heavily indebted poor countries and Rating (1=low 6=high) of Comoros?
Provide a succinct answer. 0.2. In the year 2009, what is the difference between the Rating (1=low 6=high) of Heavily indebted poor countries and Rating (1=low 6=high) of Mongolia?
Provide a succinct answer. -0.3. In the year 2009, what is the difference between the Rating (1=low 6=high) in Heavily indebted poor countries and Rating (1=low 6=high) in Vanuatu?
Ensure brevity in your answer.  -0.3. In the year 2009, what is the difference between the Rating (1=low 6=high) of Comoros and Rating (1=low 6=high) of Mongolia?
Offer a terse response. -0.5. In the year 2009, what is the difference between the Rating (1=low 6=high) of Comoros and Rating (1=low 6=high) of Vanuatu?
Offer a terse response. -0.5. In the year 2009, what is the difference between the Rating (1=low 6=high) of Mongolia and Rating (1=low 6=high) of Vanuatu?
Provide a short and direct response. 0. In the year 2010, what is the difference between the Rating (1=low 6=high) in Heavily indebted poor countries and Rating (1=low 6=high) in Comoros?
Offer a terse response. 0.16. In the year 2010, what is the difference between the Rating (1=low 6=high) in Heavily indebted poor countries and Rating (1=low 6=high) in Mongolia?
Give a very brief answer. -0.34. In the year 2010, what is the difference between the Rating (1=low 6=high) in Heavily indebted poor countries and Rating (1=low 6=high) in Vanuatu?
Provide a short and direct response. -0.34. In the year 2010, what is the difference between the Rating (1=low 6=high) of Comoros and Rating (1=low 6=high) of Mongolia?
Ensure brevity in your answer.  -0.5. In the year 2011, what is the difference between the Rating (1=low 6=high) of Heavily indebted poor countries and Rating (1=low 6=high) of Comoros?
Provide a short and direct response. 0.22. In the year 2011, what is the difference between the Rating (1=low 6=high) of Heavily indebted poor countries and Rating (1=low 6=high) of Mongolia?
Ensure brevity in your answer.  -0.78. In the year 2011, what is the difference between the Rating (1=low 6=high) of Heavily indebted poor countries and Rating (1=low 6=high) of Vanuatu?
Give a very brief answer. -0.28. In the year 2011, what is the difference between the Rating (1=low 6=high) of Comoros and Rating (1=low 6=high) of Mongolia?
Give a very brief answer. -1. In the year 2011, what is the difference between the Rating (1=low 6=high) of Comoros and Rating (1=low 6=high) of Vanuatu?
Ensure brevity in your answer.  -0.5. In the year 2012, what is the difference between the Rating (1=low 6=high) in Heavily indebted poor countries and Rating (1=low 6=high) in Comoros?
Your answer should be very brief. 0.17. In the year 2012, what is the difference between the Rating (1=low 6=high) in Heavily indebted poor countries and Rating (1=low 6=high) in Mongolia?
Give a very brief answer. -0.83. In the year 2012, what is the difference between the Rating (1=low 6=high) in Heavily indebted poor countries and Rating (1=low 6=high) in Vanuatu?
Provide a short and direct response. -0.83. In the year 2012, what is the difference between the Rating (1=low 6=high) in Comoros and Rating (1=low 6=high) in Mongolia?
Offer a terse response. -1. In the year 2012, what is the difference between the Rating (1=low 6=high) in Comoros and Rating (1=low 6=high) in Vanuatu?
Ensure brevity in your answer.  -1. In the year 2012, what is the difference between the Rating (1=low 6=high) in Mongolia and Rating (1=low 6=high) in Vanuatu?
Your response must be concise. 0. In the year 2013, what is the difference between the Rating (1=low 6=high) in Heavily indebted poor countries and Rating (1=low 6=high) in Comoros?
Offer a terse response. 0.2. In the year 2013, what is the difference between the Rating (1=low 6=high) of Heavily indebted poor countries and Rating (1=low 6=high) of Mongolia?
Offer a very short reply. -0.8. In the year 2013, what is the difference between the Rating (1=low 6=high) in Heavily indebted poor countries and Rating (1=low 6=high) in Vanuatu?
Offer a very short reply. -0.8. In the year 2013, what is the difference between the Rating (1=low 6=high) in Comoros and Rating (1=low 6=high) in Mongolia?
Provide a succinct answer. -1. In the year 2013, what is the difference between the Rating (1=low 6=high) in Comoros and Rating (1=low 6=high) in Vanuatu?
Offer a terse response. -1. In the year 2013, what is the difference between the Rating (1=low 6=high) in Mongolia and Rating (1=low 6=high) in Vanuatu?
Offer a very short reply. 0. In the year 2014, what is the difference between the Rating (1=low 6=high) of Heavily indebted poor countries and Rating (1=low 6=high) of Comoros?
Give a very brief answer. 0.24. In the year 2014, what is the difference between the Rating (1=low 6=high) of Heavily indebted poor countries and Rating (1=low 6=high) of Mongolia?
Your answer should be compact. -0.76. In the year 2014, what is the difference between the Rating (1=low 6=high) of Heavily indebted poor countries and Rating (1=low 6=high) of Vanuatu?
Your response must be concise. -0.26. In the year 2014, what is the difference between the Rating (1=low 6=high) in Comoros and Rating (1=low 6=high) in Vanuatu?
Give a very brief answer. -0.5. What is the ratio of the Rating (1=low 6=high) in Heavily indebted poor countries in 2007 to that in 2008?
Offer a terse response. 1.01. What is the ratio of the Rating (1=low 6=high) in Comoros in 2007 to that in 2008?
Provide a succinct answer. 1. What is the ratio of the Rating (1=low 6=high) in Heavily indebted poor countries in 2007 to that in 2010?
Give a very brief answer. 1.03. What is the ratio of the Rating (1=low 6=high) in Comoros in 2007 to that in 2010?
Keep it short and to the point. 1. What is the ratio of the Rating (1=low 6=high) in Heavily indebted poor countries in 2007 to that in 2011?
Provide a short and direct response. 1.01. What is the ratio of the Rating (1=low 6=high) in Comoros in 2007 to that in 2011?
Give a very brief answer. 1. What is the ratio of the Rating (1=low 6=high) of Heavily indebted poor countries in 2007 to that in 2012?
Give a very brief answer. 1.03. What is the ratio of the Rating (1=low 6=high) in Comoros in 2007 to that in 2012?
Offer a terse response. 1. What is the ratio of the Rating (1=low 6=high) in Heavily indebted poor countries in 2007 to that in 2013?
Keep it short and to the point. 1.02. What is the ratio of the Rating (1=low 6=high) of Mongolia in 2007 to that in 2013?
Provide a succinct answer. 0.86. What is the ratio of the Rating (1=low 6=high) of Vanuatu in 2007 to that in 2013?
Provide a short and direct response. 0.86. What is the ratio of the Rating (1=low 6=high) of Heavily indebted poor countries in 2007 to that in 2014?
Your answer should be compact. 1. What is the ratio of the Rating (1=low 6=high) in Vanuatu in 2007 to that in 2014?
Give a very brief answer. 1. What is the ratio of the Rating (1=low 6=high) in Comoros in 2008 to that in 2009?
Your answer should be very brief. 1. What is the ratio of the Rating (1=low 6=high) of Mongolia in 2008 to that in 2009?
Keep it short and to the point. 1. What is the ratio of the Rating (1=low 6=high) in Heavily indebted poor countries in 2008 to that in 2010?
Offer a very short reply. 1.02. What is the ratio of the Rating (1=low 6=high) of Comoros in 2008 to that in 2010?
Your response must be concise. 1. What is the ratio of the Rating (1=low 6=high) of Mongolia in 2008 to that in 2010?
Your response must be concise. 1. What is the ratio of the Rating (1=low 6=high) of Heavily indebted poor countries in 2008 to that in 2011?
Provide a succinct answer. 1. What is the ratio of the Rating (1=low 6=high) in Heavily indebted poor countries in 2008 to that in 2012?
Your answer should be compact. 1.02. What is the ratio of the Rating (1=low 6=high) in Mongolia in 2008 to that in 2012?
Keep it short and to the point. 0.86. What is the ratio of the Rating (1=low 6=high) of Vanuatu in 2008 to that in 2012?
Your answer should be compact. 0.86. What is the ratio of the Rating (1=low 6=high) of Vanuatu in 2008 to that in 2013?
Give a very brief answer. 0.86. What is the ratio of the Rating (1=low 6=high) in Comoros in 2008 to that in 2014?
Your answer should be very brief. 1. What is the ratio of the Rating (1=low 6=high) of Vanuatu in 2008 to that in 2014?
Keep it short and to the point. 1. What is the ratio of the Rating (1=low 6=high) in Heavily indebted poor countries in 2009 to that in 2010?
Keep it short and to the point. 1.01. What is the ratio of the Rating (1=low 6=high) in Comoros in 2009 to that in 2010?
Give a very brief answer. 1. What is the ratio of the Rating (1=low 6=high) of Heavily indebted poor countries in 2009 to that in 2011?
Your answer should be compact. 0.99. What is the ratio of the Rating (1=low 6=high) of Vanuatu in 2009 to that in 2011?
Give a very brief answer. 1. What is the ratio of the Rating (1=low 6=high) of Heavily indebted poor countries in 2009 to that in 2012?
Your answer should be compact. 1.01. What is the ratio of the Rating (1=low 6=high) in Mongolia in 2009 to that in 2012?
Your response must be concise. 0.86. What is the ratio of the Rating (1=low 6=high) of Vanuatu in 2009 to that in 2012?
Make the answer very short. 0.86. What is the ratio of the Rating (1=low 6=high) in Heavily indebted poor countries in 2009 to that in 2013?
Give a very brief answer. 1. What is the ratio of the Rating (1=low 6=high) of Comoros in 2009 to that in 2013?
Ensure brevity in your answer.  1. What is the ratio of the Rating (1=low 6=high) of Vanuatu in 2009 to that in 2013?
Provide a short and direct response. 0.86. What is the ratio of the Rating (1=low 6=high) in Heavily indebted poor countries in 2009 to that in 2014?
Provide a short and direct response. 0.99. What is the ratio of the Rating (1=low 6=high) in Comoros in 2009 to that in 2014?
Give a very brief answer. 1. What is the ratio of the Rating (1=low 6=high) in Mongolia in 2009 to that in 2014?
Give a very brief answer. 0.86. What is the ratio of the Rating (1=low 6=high) of Vanuatu in 2009 to that in 2014?
Your answer should be very brief. 1. What is the ratio of the Rating (1=low 6=high) in Heavily indebted poor countries in 2010 to that in 2011?
Your answer should be compact. 0.98. What is the ratio of the Rating (1=low 6=high) in Vanuatu in 2010 to that in 2011?
Provide a short and direct response. 1. What is the ratio of the Rating (1=low 6=high) in Heavily indebted poor countries in 2010 to that in 2012?
Give a very brief answer. 1. What is the ratio of the Rating (1=low 6=high) in Comoros in 2010 to that in 2012?
Offer a terse response. 1. What is the ratio of the Rating (1=low 6=high) of Vanuatu in 2010 to that in 2012?
Your answer should be very brief. 0.86. What is the ratio of the Rating (1=low 6=high) of Heavily indebted poor countries in 2010 to that in 2013?
Your answer should be compact. 0.99. What is the ratio of the Rating (1=low 6=high) in Mongolia in 2010 to that in 2013?
Your answer should be compact. 0.86. What is the ratio of the Rating (1=low 6=high) in Heavily indebted poor countries in 2010 to that in 2014?
Give a very brief answer. 0.97. What is the ratio of the Rating (1=low 6=high) in Heavily indebted poor countries in 2011 to that in 2012?
Offer a terse response. 1.02. What is the ratio of the Rating (1=low 6=high) in Comoros in 2011 to that in 2012?
Provide a short and direct response. 1. What is the ratio of the Rating (1=low 6=high) in Mongolia in 2011 to that in 2012?
Provide a short and direct response. 1. What is the ratio of the Rating (1=low 6=high) in Heavily indebted poor countries in 2011 to that in 2013?
Your response must be concise. 1.01. What is the ratio of the Rating (1=low 6=high) of Comoros in 2011 to that in 2013?
Make the answer very short. 1. What is the ratio of the Rating (1=low 6=high) in Mongolia in 2011 to that in 2013?
Provide a short and direct response. 1. What is the ratio of the Rating (1=low 6=high) of Vanuatu in 2011 to that in 2013?
Give a very brief answer. 0.86. What is the ratio of the Rating (1=low 6=high) in Comoros in 2011 to that in 2014?
Offer a very short reply. 1. What is the ratio of the Rating (1=low 6=high) of Mongolia in 2011 to that in 2014?
Your response must be concise. 1. What is the ratio of the Rating (1=low 6=high) of Heavily indebted poor countries in 2012 to that in 2013?
Ensure brevity in your answer.  0.99. What is the ratio of the Rating (1=low 6=high) of Mongolia in 2012 to that in 2013?
Your answer should be very brief. 1. What is the ratio of the Rating (1=low 6=high) in Heavily indebted poor countries in 2013 to that in 2014?
Your response must be concise. 0.99. What is the ratio of the Rating (1=low 6=high) of Comoros in 2013 to that in 2014?
Provide a short and direct response. 1. What is the ratio of the Rating (1=low 6=high) in Vanuatu in 2013 to that in 2014?
Keep it short and to the point. 1.17. What is the difference between the highest and the second highest Rating (1=low 6=high) in Heavily indebted poor countries?
Your response must be concise. 0.01. What is the difference between the highest and the second highest Rating (1=low 6=high) of Comoros?
Keep it short and to the point. 0. What is the difference between the highest and the lowest Rating (1=low 6=high) of Heavily indebted poor countries?
Provide a succinct answer. 0.09. What is the difference between the highest and the lowest Rating (1=low 6=high) of Comoros?
Your answer should be compact. 0. What is the difference between the highest and the lowest Rating (1=low 6=high) of Vanuatu?
Your response must be concise. 0.5. 